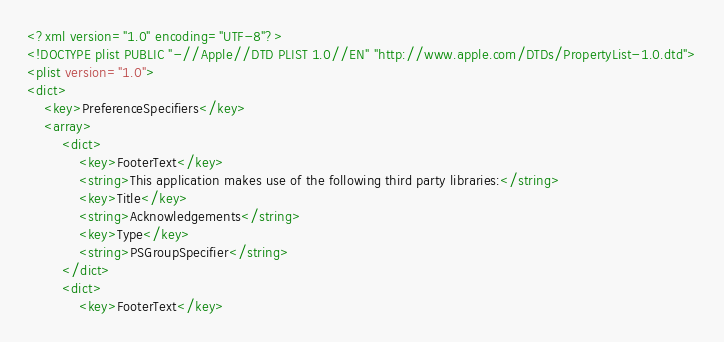<code> <loc_0><loc_0><loc_500><loc_500><_XML_><?xml version="1.0" encoding="UTF-8"?>
<!DOCTYPE plist PUBLIC "-//Apple//DTD PLIST 1.0//EN" "http://www.apple.com/DTDs/PropertyList-1.0.dtd">
<plist version="1.0">
<dict>
	<key>PreferenceSpecifiers</key>
	<array>
		<dict>
			<key>FooterText</key>
			<string>This application makes use of the following third party libraries:</string>
			<key>Title</key>
			<string>Acknowledgements</string>
			<key>Type</key>
			<string>PSGroupSpecifier</string>
		</dict>
		<dict>
			<key>FooterText</key></code> 